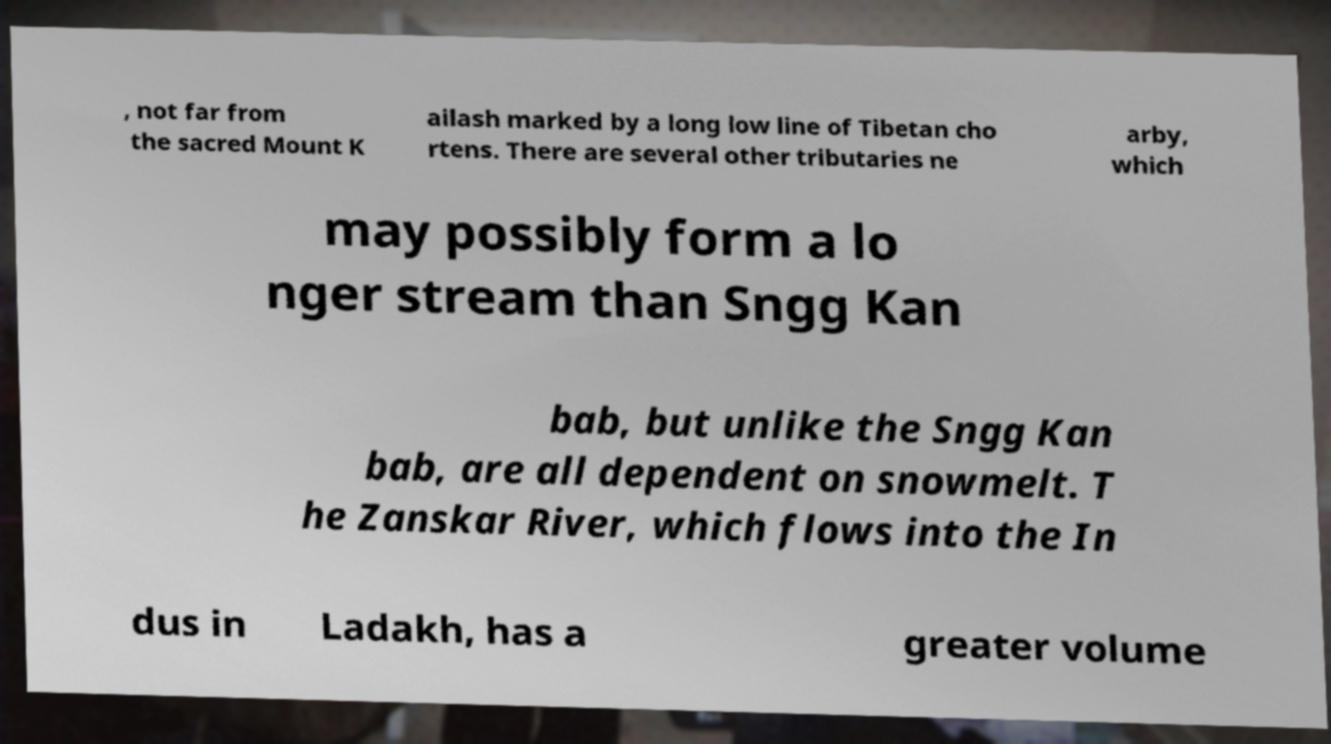For documentation purposes, I need the text within this image transcribed. Could you provide that? , not far from the sacred Mount K ailash marked by a long low line of Tibetan cho rtens. There are several other tributaries ne arby, which may possibly form a lo nger stream than Sngg Kan bab, but unlike the Sngg Kan bab, are all dependent on snowmelt. T he Zanskar River, which flows into the In dus in Ladakh, has a greater volume 